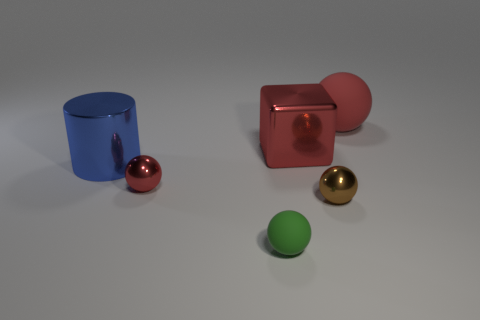Add 4 small green matte things. How many objects exist? 10 Subtract all cylinders. How many objects are left? 5 Add 2 large red rubber balls. How many large red rubber balls are left? 3 Add 6 big things. How many big things exist? 9 Subtract 0 purple cylinders. How many objects are left? 6 Subtract all tiny brown objects. Subtract all red shiny balls. How many objects are left? 4 